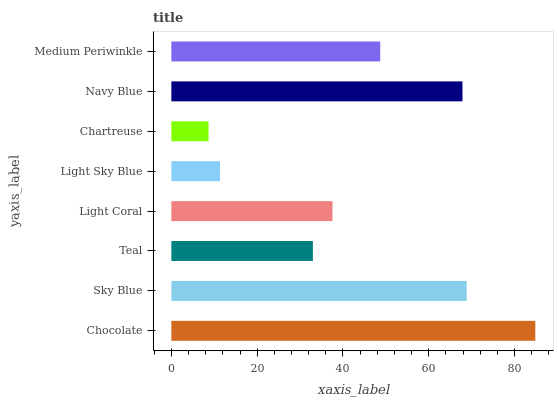Is Chartreuse the minimum?
Answer yes or no. Yes. Is Chocolate the maximum?
Answer yes or no. Yes. Is Sky Blue the minimum?
Answer yes or no. No. Is Sky Blue the maximum?
Answer yes or no. No. Is Chocolate greater than Sky Blue?
Answer yes or no. Yes. Is Sky Blue less than Chocolate?
Answer yes or no. Yes. Is Sky Blue greater than Chocolate?
Answer yes or no. No. Is Chocolate less than Sky Blue?
Answer yes or no. No. Is Medium Periwinkle the high median?
Answer yes or no. Yes. Is Light Coral the low median?
Answer yes or no. Yes. Is Light Sky Blue the high median?
Answer yes or no. No. Is Navy Blue the low median?
Answer yes or no. No. 